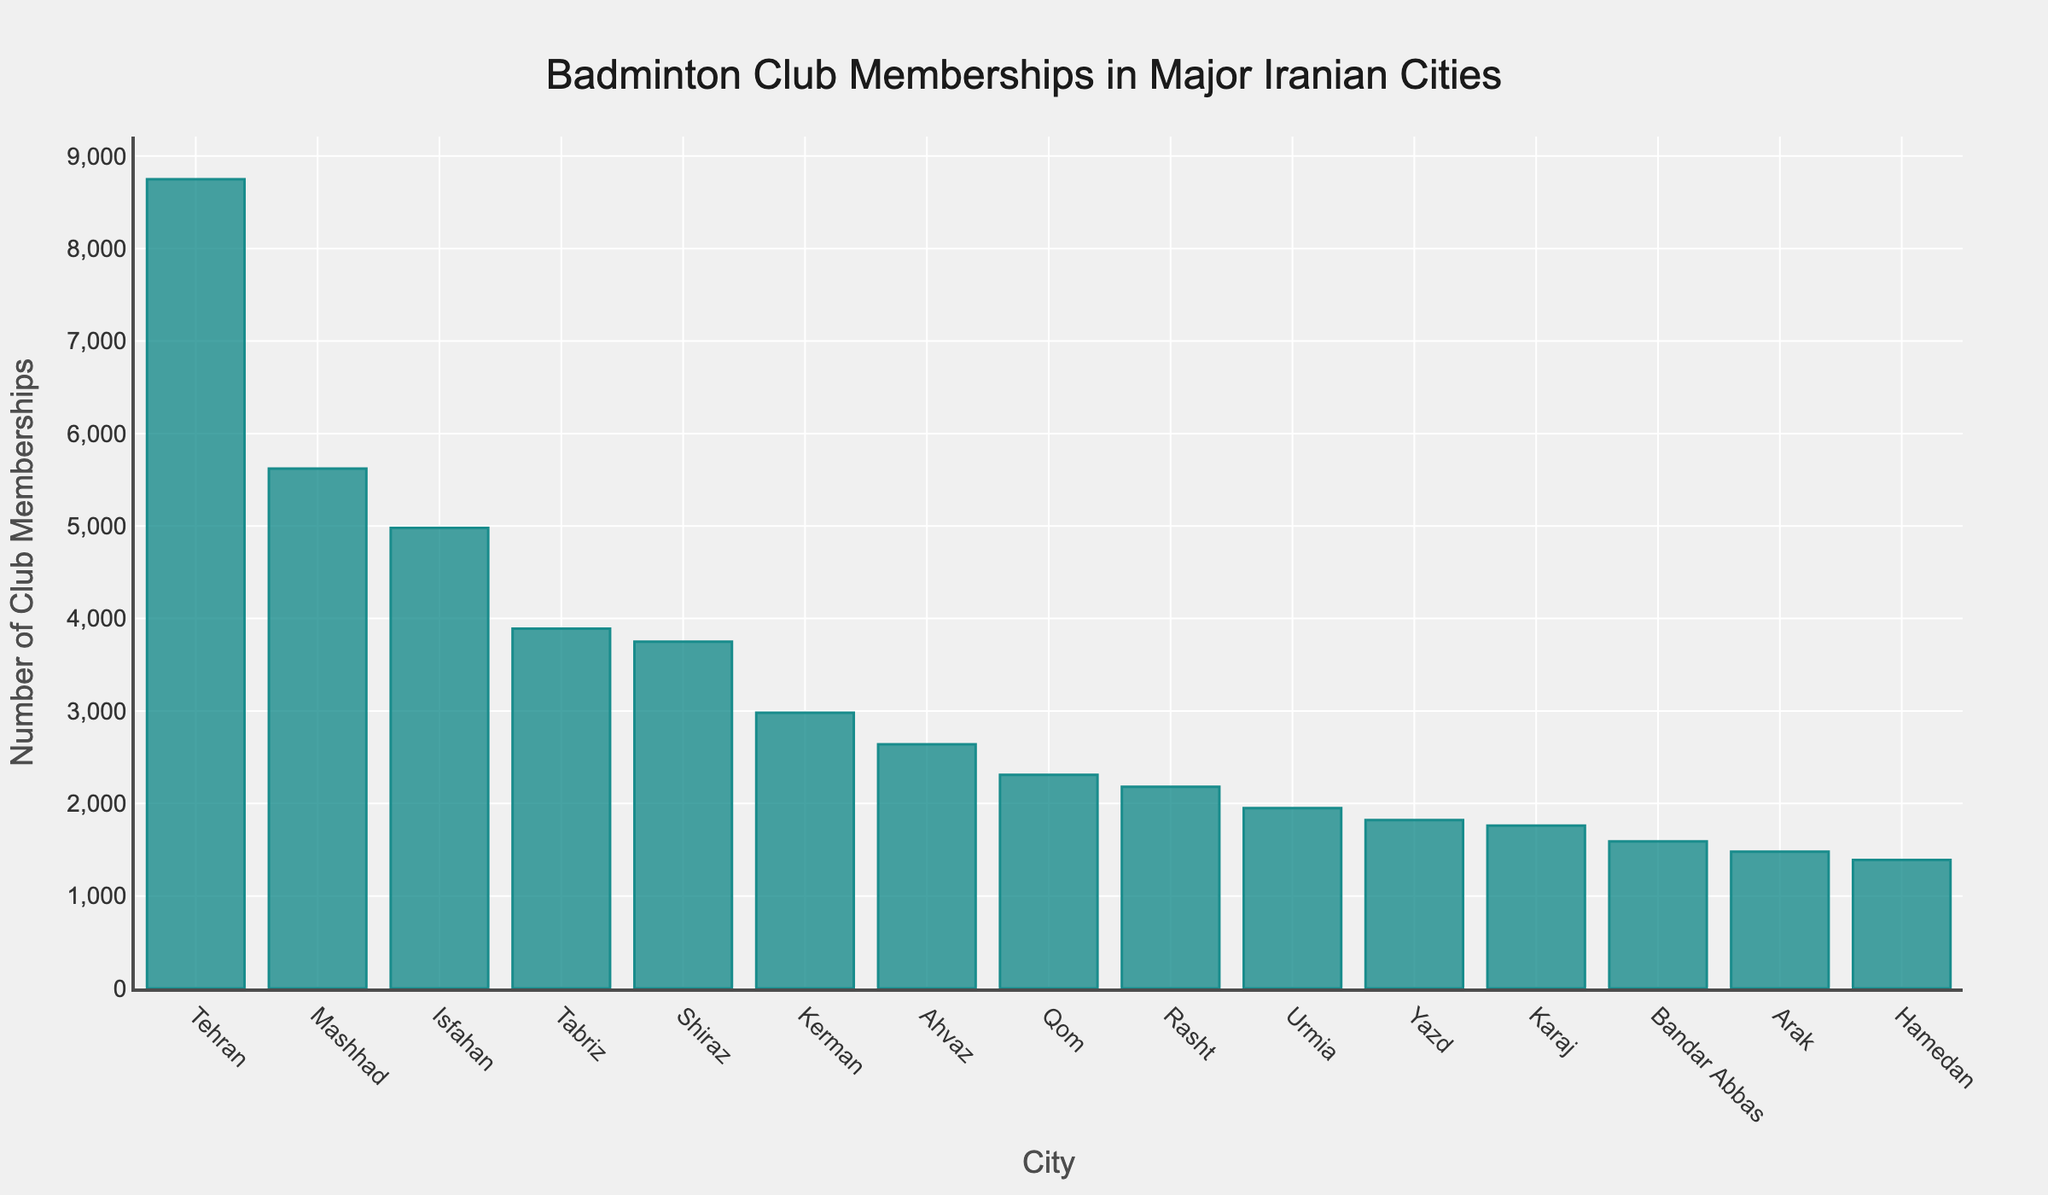What is the city with the highest number of badminton club memberships? The bar chart displays the highest bar for Tehran, indicating it has the most memberships.
Answer: Tehran Which city has more badminton club memberships, Tabriz or Shiraz? Tabriz has a bar height slightly above Shiraz's, indicating Tabriz has more memberships.
Answer: Tabriz What's the difference in badminton club memberships between Tehran and Karaj? Tehran's bar represents 8750 memberships, and Karaj's bar represents 1760. The difference is 8750 - 1760 = 6990.
Answer: 6990 Which city has fewer memberships, Ahvaz or Rasht? Ahvaz's bar is taller than Rasht's, indicating Ahvaz has more memberships. Therefore, Rasht has fewer memberships.
Answer: Rasht What is the total number of badminton club memberships in Tehran, Mashhad, and Isfahan? Sum of memberships: Tehran (8750) + Mashhad (5620) + Isfahan (4980) = 19350.
Answer: 19350 How many more memberships does Urmia have compared to Yazd? Urmia has 1950 memberships and Yazd has 1820. The difference is 1950 - 1820 = 130.
Answer: 130 What is the average number of club memberships in the top three cities? Sum of top three cities' memberships: Tehran (8750) + Mashhad (5620) + Isfahan (4980) = 19350. The average is 19350 / 3 = 6450.
Answer: 6450 Which city has the lowest number of badminton club memberships? The lowest bar represents Hamedan, indicating it has the fewest memberships.
Answer: Hamedan Compare the total memberships of Kerman and Yazd to that of Shiraz. Which is more? Kerman (2980) + Yazd (1820) = 4800. Shiraz has 3750 memberships. Therefore, Kerman and Yazd combined have more memberships than Shiraz.
Answer: Kerman and Yazd What is the difference in memberships between the second highest and the second lowest city on the chart? The second highest is Mashhad (5620), and the second lowest is Arak (1480). The difference is 5620 - 1480 = 4140.
Answer: 4140 